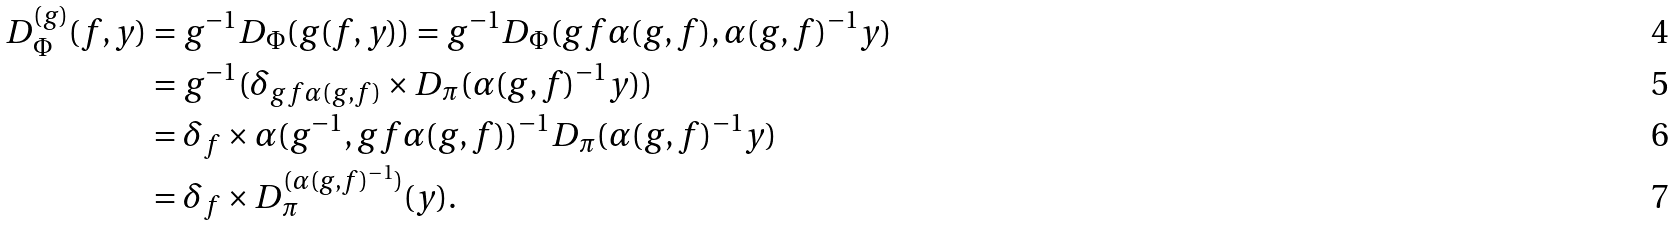<formula> <loc_0><loc_0><loc_500><loc_500>D _ { \Phi } ^ { ( g ) } ( f , y ) & = g ^ { - 1 } D _ { \Phi } ( g ( f , y ) ) = g ^ { - 1 } D _ { \Phi } ( g f \alpha ( g , f ) , \alpha ( g , f ) ^ { - 1 } y ) \\ & = g ^ { - 1 } ( \delta _ { g f \alpha ( g , f ) } \times D _ { \pi } ( \alpha ( g , f ) ^ { - 1 } y ) ) \\ & = \delta _ { f } \times \alpha ( g ^ { - 1 } , g f \alpha ( g , f ) ) ^ { - 1 } D _ { \pi } ( \alpha ( g , f ) ^ { - 1 } y ) \\ & = \delta _ { f } \times D _ { \pi } ^ { ( \alpha ( g , f ) ^ { - 1 } ) } ( y ) .</formula> 